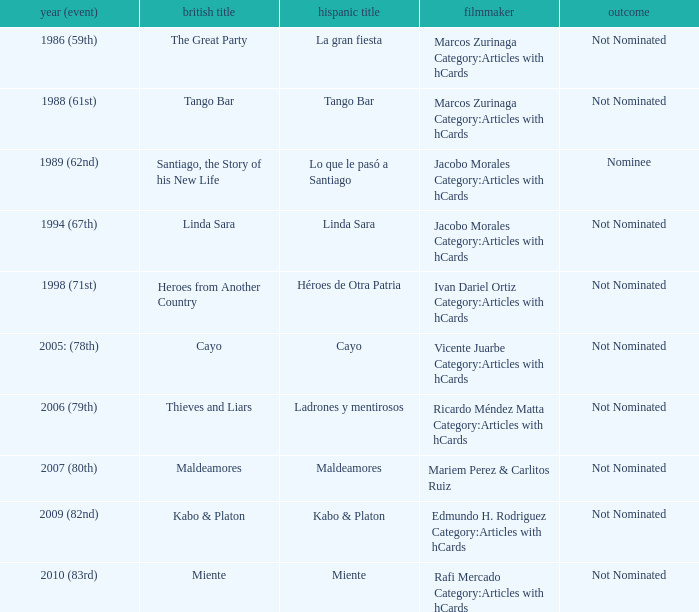Who was the director for Tango Bar? Marcos Zurinaga Category:Articles with hCards. 